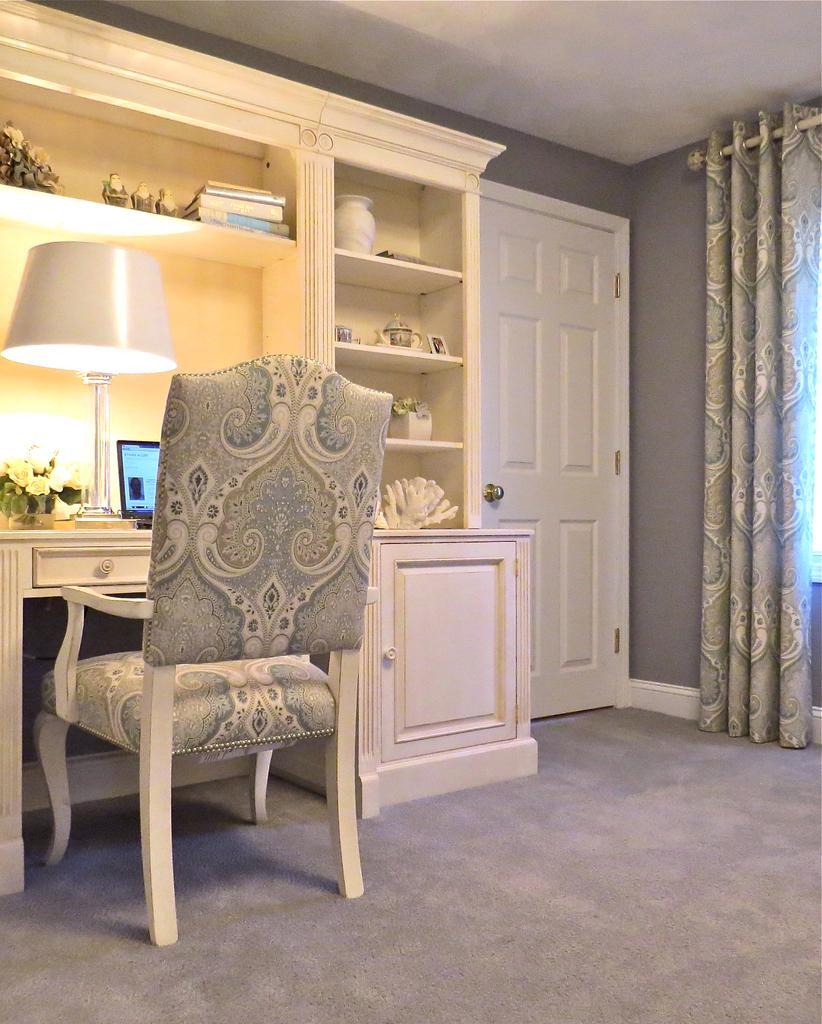Can you describe this image briefly? there is a room in which there is a chair. in front of it there is a cupboard, laptop, lamp and flowers. at the right there is a white door and curtains. 